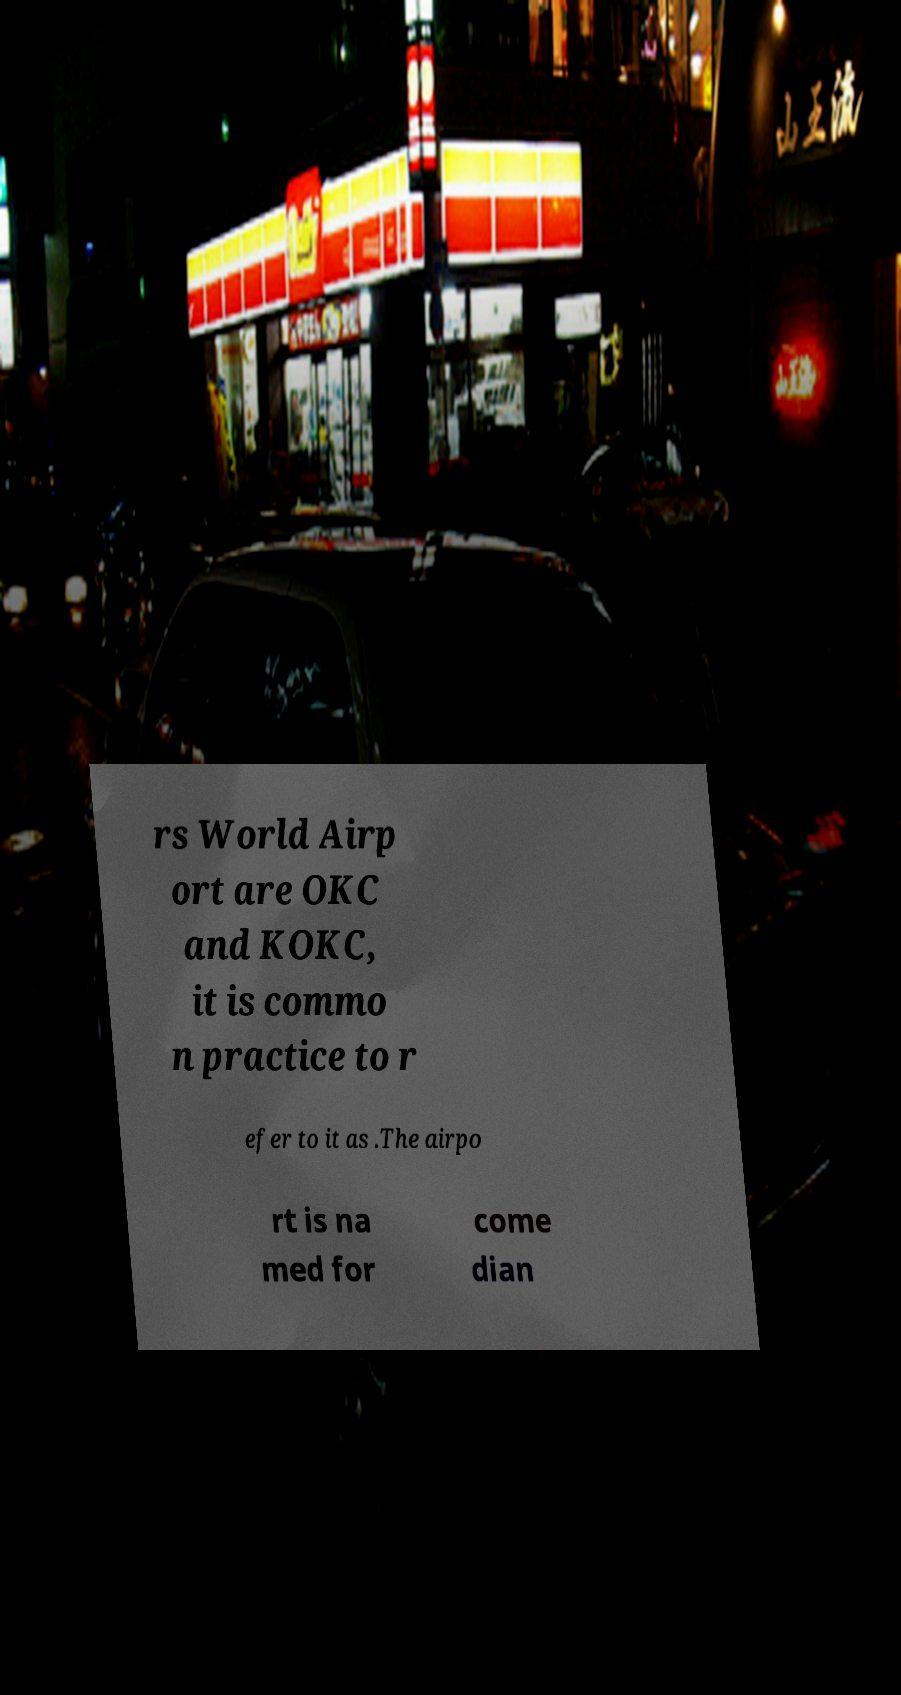Can you accurately transcribe the text from the provided image for me? rs World Airp ort are OKC and KOKC, it is commo n practice to r efer to it as .The airpo rt is na med for come dian 